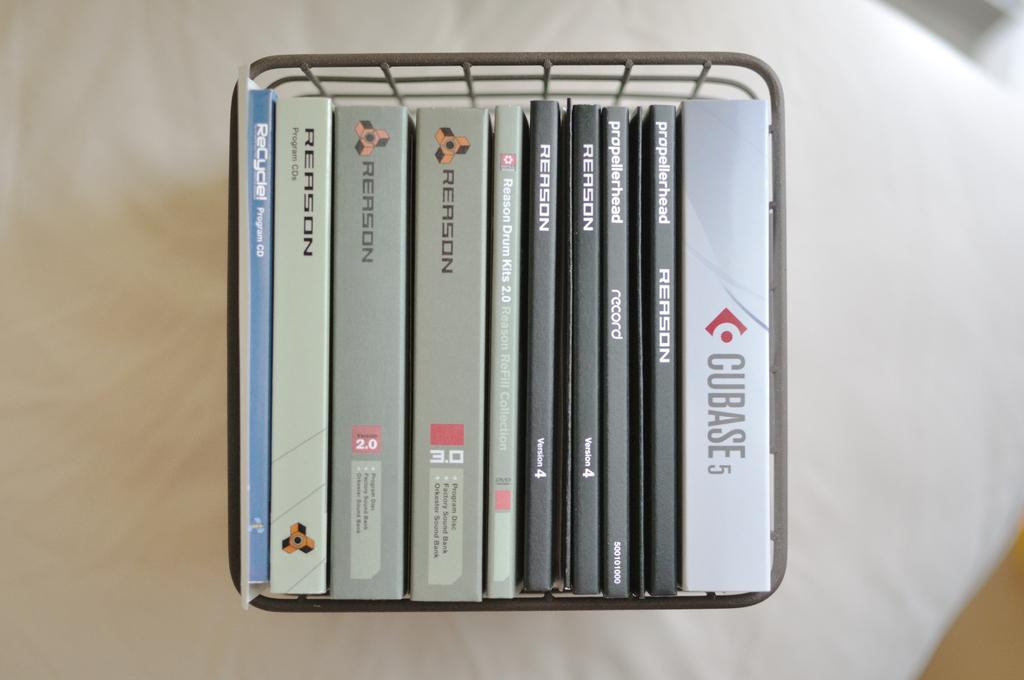Provide a one-sentence caption for the provided image. A wire basket holds CD sleeves, including one for Cubase 5. 